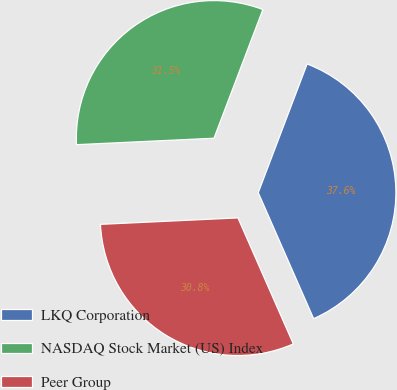Convert chart to OTSL. <chart><loc_0><loc_0><loc_500><loc_500><pie_chart><fcel>LKQ Corporation<fcel>NASDAQ Stock Market (US) Index<fcel>Peer Group<nl><fcel>37.63%<fcel>31.52%<fcel>30.84%<nl></chart> 